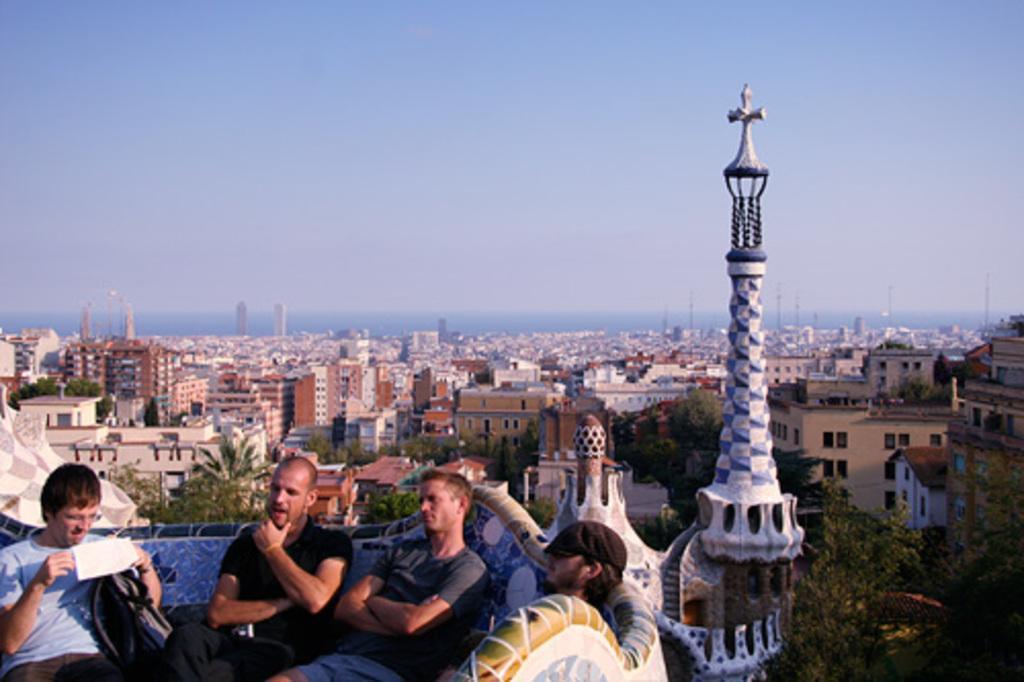In one or two sentences, can you explain what this image depicts? In this image we can see there are persons sitting on the sofa. At the back there are buildings, trees and the sky. 